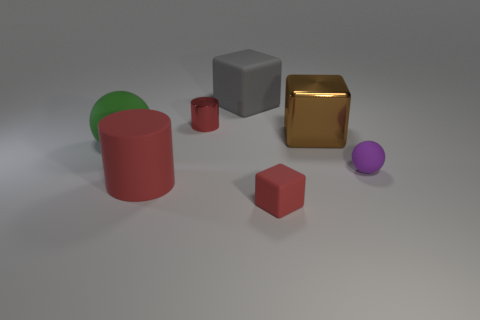How many cubes are tiny cyan metallic objects or green things?
Provide a short and direct response. 0. There is a shiny object on the left side of the red rubber object that is in front of the red matte thing on the left side of the tiny red metallic cylinder; what shape is it?
Give a very brief answer. Cylinder. What is the shape of the matte object that is the same color as the rubber cylinder?
Provide a succinct answer. Cube. How many gray matte things are the same size as the green rubber ball?
Offer a terse response. 1. Are there any purple matte balls to the right of the shiny object that is in front of the tiny metal cylinder?
Offer a very short reply. Yes. How many objects are either red matte things or tiny red matte cubes?
Give a very brief answer. 2. There is a matte sphere that is to the right of the small red thing behind the ball to the left of the large gray rubber block; what color is it?
Provide a short and direct response. Purple. Is there any other thing that is the same color as the tiny cube?
Provide a short and direct response. Yes. Is the size of the brown shiny object the same as the gray rubber object?
Keep it short and to the point. Yes. How many objects are either matte objects behind the green sphere or small objects that are in front of the red metallic cylinder?
Your answer should be compact. 3. 